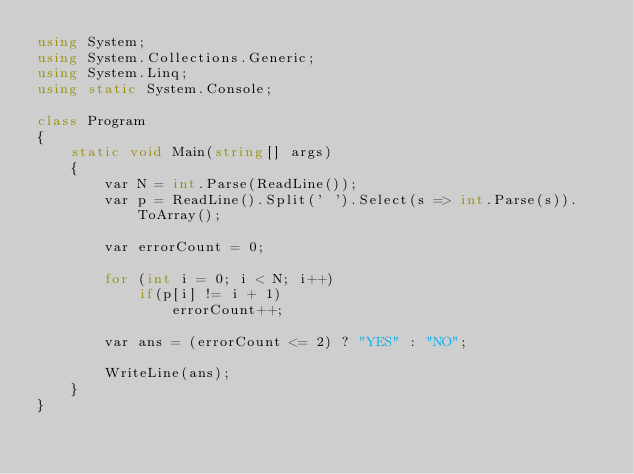<code> <loc_0><loc_0><loc_500><loc_500><_C#_>using System;
using System.Collections.Generic;
using System.Linq;
using static System.Console;

class Program
{
    static void Main(string[] args)
    {
        var N = int.Parse(ReadLine());
        var p = ReadLine().Split(' ').Select(s => int.Parse(s)).ToArray();

        var errorCount = 0;

        for (int i = 0; i < N; i++)
            if(p[i] != i + 1)
                errorCount++;

        var ans = (errorCount <= 2) ? "YES" : "NO";

        WriteLine(ans);
    }
}
</code> 